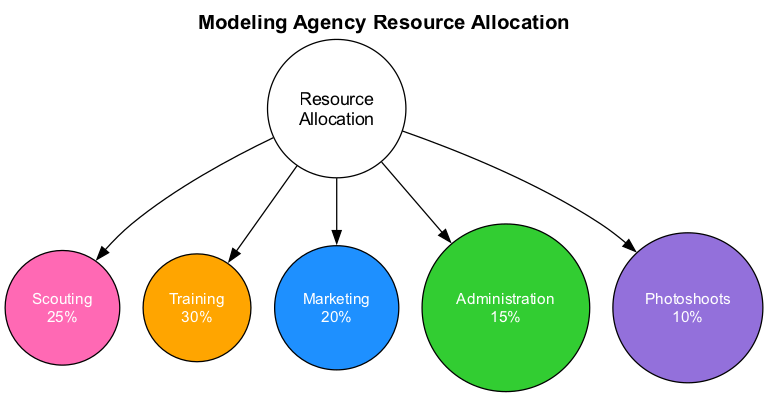What percentage of resources is allocated to Scouting? The diagram shows that the Scouting department has been assigned 25% of the total resources, as indicated by the percentage displayed in its node.
Answer: 25% How many departments are represented in the diagram? By counting each department node connected to the center, we find a total of five departments: Scouting, Training, Marketing, Administration, and Photoshoots.
Answer: 5 Which department has the lowest resource allocation? Comparing the percentages across all departments, Photoshoots has the lowest allocation at 10%. This is visible in the node for Photoshoots.
Answer: Photoshoots What is the total percentage allocated to Training and Marketing combined? Adding the percentages of Training (30%) and Marketing (20%) gives us a combined total of 50%.
Answer: 50% Which department is allocated the most resources? By evaluating each department's percentage, we find that the Training department, with 30%, has the highest allocation compared to others.
Answer: Training What color represents the Administration department? The node for Administration is filled with the color green (#32CD32), which is noted within the diagram.
Answer: Green Explain the relationship between Scouting and Training in terms of resource allocation. The Scouting department is allocated 25% while the Training department is allocated 30%. Since Training has a higher percentage, it shows that more resources are committed to Training compared to Scouting.
Answer: Training has more resources than Scouting What is the representation of the percentage allocation for Marketing? The Marketing department is represented by a percentage allocation of 20%, which is displayed in its corresponding node within the diagram.
Answer: 20% 